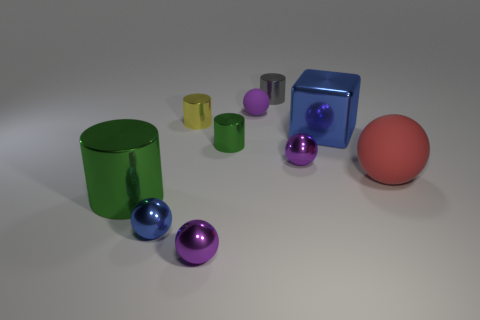There is a purple metal object behind the large sphere; does it have the same shape as the tiny gray object?
Your answer should be very brief. No. What number of blue things are either shiny balls or small shiny blocks?
Provide a short and direct response. 1. Is the number of blue cubes greater than the number of small purple metallic balls?
Offer a terse response. No. There is a metal cube that is the same size as the red ball; what is its color?
Offer a very short reply. Blue. What number of cubes are either small blue metallic objects or big things?
Your answer should be compact. 1. Do the small gray shiny thing and the big object that is in front of the big red matte sphere have the same shape?
Provide a succinct answer. Yes. What number of blue objects have the same size as the purple rubber thing?
Your answer should be very brief. 1. Does the blue metallic object right of the gray cylinder have the same shape as the green metal object that is on the right side of the big green metal object?
Offer a terse response. No. The object that is the same color as the large block is what shape?
Provide a succinct answer. Sphere. What is the color of the large object behind the small shiny thing that is right of the gray shiny cylinder?
Provide a succinct answer. Blue. 